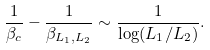<formula> <loc_0><loc_0><loc_500><loc_500>\frac { 1 } { \beta _ { c } } - \frac { 1 } { \beta _ { L _ { 1 } , L _ { 2 } } } \sim \frac { 1 } { \log ( L _ { 1 } / L _ { 2 } ) } .</formula> 